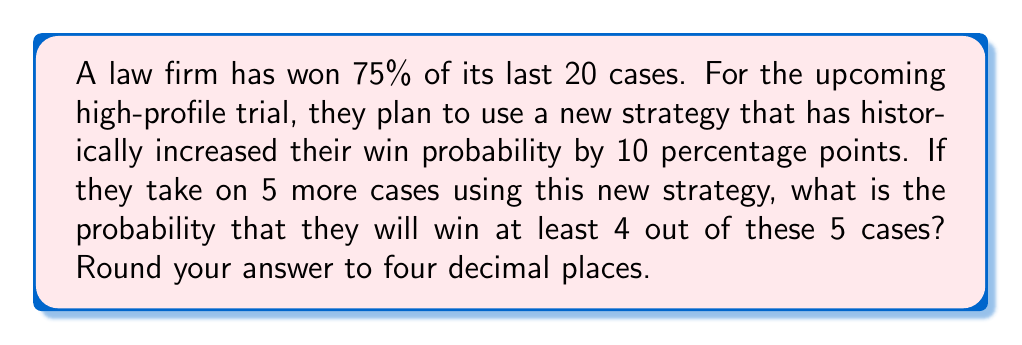Could you help me with this problem? To solve this problem, we'll use the binomial probability distribution and the given information:

1. The law firm's base win rate is 75% or 0.75
2. The new strategy increases the win rate by 10 percentage points, so the new win probability is 0.85

Let $X$ be the number of cases won out of 5. We need to find $P(X \geq 4)$.

Using the binomial probability formula:

$P(X = k) = \binom{n}{k} p^k (1-p)^{n-k}$

Where:
$n = 5$ (total number of cases)
$p = 0.85$ (probability of winning a single case)
$k = 4$ or $5$ (number of successful outcomes)

We need to calculate $P(X = 4) + P(X = 5)$:

For $k = 4$:
$$P(X = 4) = \binom{5}{4} (0.85)^4 (1-0.85)^{5-4} = 5 \cdot 0.85^4 \cdot 0.15^1 = 0.3874$$

For $k = 5$:
$$P(X = 5) = \binom{5}{5} (0.85)^5 (1-0.85)^{5-5} = 1 \cdot 0.85^5 \cdot 0.15^0 = 0.4437$$

Therefore, the probability of winning at least 4 out of 5 cases is:

$$P(X \geq 4) = P(X = 4) + P(X = 5) = 0.3874 + 0.4437 = 0.8311$$

Rounding to four decimal places, we get 0.8311.
Answer: 0.8311 